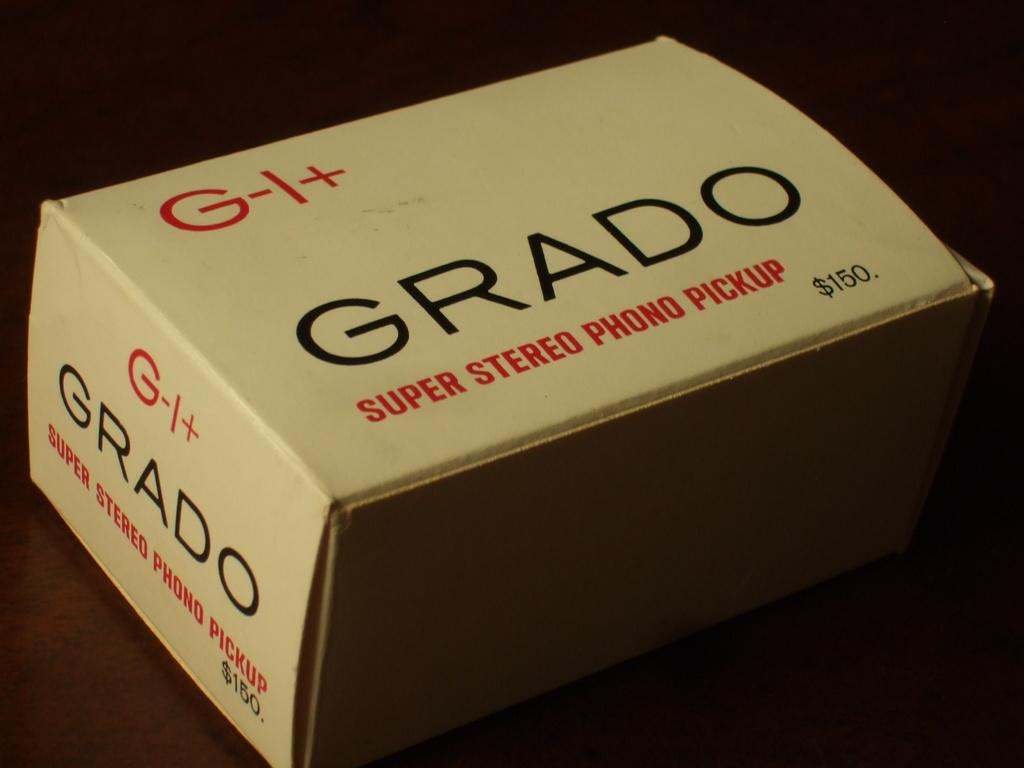<image>
Give a short and clear explanation of the subsequent image. brown box labeled grado super stereo phono pickup priced at $150 